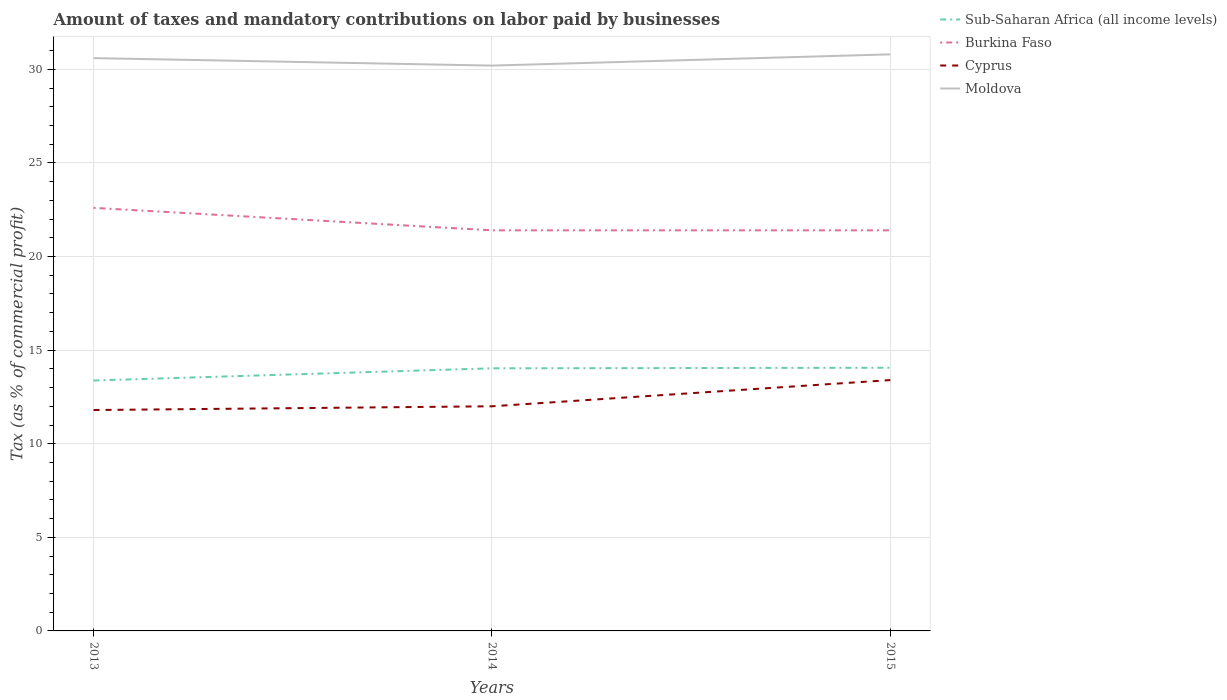How many different coloured lines are there?
Your answer should be compact. 4. Across all years, what is the maximum percentage of taxes paid by businesses in Sub-Saharan Africa (all income levels)?
Provide a short and direct response. 13.38. What is the total percentage of taxes paid by businesses in Sub-Saharan Africa (all income levels) in the graph?
Offer a very short reply. -0.68. What is the difference between the highest and the second highest percentage of taxes paid by businesses in Sub-Saharan Africa (all income levels)?
Provide a succinct answer. 0.68. Is the percentage of taxes paid by businesses in Sub-Saharan Africa (all income levels) strictly greater than the percentage of taxes paid by businesses in Burkina Faso over the years?
Ensure brevity in your answer.  Yes. What is the difference between two consecutive major ticks on the Y-axis?
Provide a succinct answer. 5. Does the graph contain any zero values?
Give a very brief answer. No. How many legend labels are there?
Provide a succinct answer. 4. How are the legend labels stacked?
Give a very brief answer. Vertical. What is the title of the graph?
Give a very brief answer. Amount of taxes and mandatory contributions on labor paid by businesses. Does "Ecuador" appear as one of the legend labels in the graph?
Make the answer very short. No. What is the label or title of the Y-axis?
Provide a succinct answer. Tax (as % of commercial profit). What is the Tax (as % of commercial profit) of Sub-Saharan Africa (all income levels) in 2013?
Offer a terse response. 13.38. What is the Tax (as % of commercial profit) of Burkina Faso in 2013?
Your answer should be compact. 22.6. What is the Tax (as % of commercial profit) of Moldova in 2013?
Your answer should be very brief. 30.6. What is the Tax (as % of commercial profit) in Sub-Saharan Africa (all income levels) in 2014?
Provide a succinct answer. 14.03. What is the Tax (as % of commercial profit) of Burkina Faso in 2014?
Your answer should be compact. 21.4. What is the Tax (as % of commercial profit) in Cyprus in 2014?
Keep it short and to the point. 12. What is the Tax (as % of commercial profit) of Moldova in 2014?
Offer a terse response. 30.2. What is the Tax (as % of commercial profit) of Sub-Saharan Africa (all income levels) in 2015?
Offer a very short reply. 14.06. What is the Tax (as % of commercial profit) in Burkina Faso in 2015?
Offer a very short reply. 21.4. What is the Tax (as % of commercial profit) of Moldova in 2015?
Provide a succinct answer. 30.8. Across all years, what is the maximum Tax (as % of commercial profit) of Sub-Saharan Africa (all income levels)?
Provide a short and direct response. 14.06. Across all years, what is the maximum Tax (as % of commercial profit) of Burkina Faso?
Your answer should be very brief. 22.6. Across all years, what is the maximum Tax (as % of commercial profit) in Moldova?
Keep it short and to the point. 30.8. Across all years, what is the minimum Tax (as % of commercial profit) in Sub-Saharan Africa (all income levels)?
Offer a very short reply. 13.38. Across all years, what is the minimum Tax (as % of commercial profit) in Burkina Faso?
Offer a very short reply. 21.4. Across all years, what is the minimum Tax (as % of commercial profit) in Cyprus?
Keep it short and to the point. 11.8. Across all years, what is the minimum Tax (as % of commercial profit) of Moldova?
Your answer should be compact. 30.2. What is the total Tax (as % of commercial profit) in Sub-Saharan Africa (all income levels) in the graph?
Your answer should be very brief. 41.46. What is the total Tax (as % of commercial profit) of Burkina Faso in the graph?
Offer a terse response. 65.4. What is the total Tax (as % of commercial profit) of Cyprus in the graph?
Provide a succinct answer. 37.2. What is the total Tax (as % of commercial profit) of Moldova in the graph?
Offer a very short reply. 91.6. What is the difference between the Tax (as % of commercial profit) in Sub-Saharan Africa (all income levels) in 2013 and that in 2014?
Your answer should be very brief. -0.65. What is the difference between the Tax (as % of commercial profit) in Cyprus in 2013 and that in 2014?
Give a very brief answer. -0.2. What is the difference between the Tax (as % of commercial profit) in Sub-Saharan Africa (all income levels) in 2013 and that in 2015?
Provide a succinct answer. -0.68. What is the difference between the Tax (as % of commercial profit) of Moldova in 2013 and that in 2015?
Keep it short and to the point. -0.2. What is the difference between the Tax (as % of commercial profit) in Sub-Saharan Africa (all income levels) in 2014 and that in 2015?
Offer a very short reply. -0.03. What is the difference between the Tax (as % of commercial profit) of Cyprus in 2014 and that in 2015?
Your response must be concise. -1.4. What is the difference between the Tax (as % of commercial profit) in Moldova in 2014 and that in 2015?
Make the answer very short. -0.6. What is the difference between the Tax (as % of commercial profit) of Sub-Saharan Africa (all income levels) in 2013 and the Tax (as % of commercial profit) of Burkina Faso in 2014?
Offer a very short reply. -8.02. What is the difference between the Tax (as % of commercial profit) in Sub-Saharan Africa (all income levels) in 2013 and the Tax (as % of commercial profit) in Cyprus in 2014?
Your answer should be compact. 1.38. What is the difference between the Tax (as % of commercial profit) of Sub-Saharan Africa (all income levels) in 2013 and the Tax (as % of commercial profit) of Moldova in 2014?
Make the answer very short. -16.82. What is the difference between the Tax (as % of commercial profit) in Burkina Faso in 2013 and the Tax (as % of commercial profit) in Moldova in 2014?
Provide a succinct answer. -7.6. What is the difference between the Tax (as % of commercial profit) in Cyprus in 2013 and the Tax (as % of commercial profit) in Moldova in 2014?
Give a very brief answer. -18.4. What is the difference between the Tax (as % of commercial profit) of Sub-Saharan Africa (all income levels) in 2013 and the Tax (as % of commercial profit) of Burkina Faso in 2015?
Ensure brevity in your answer.  -8.02. What is the difference between the Tax (as % of commercial profit) in Sub-Saharan Africa (all income levels) in 2013 and the Tax (as % of commercial profit) in Cyprus in 2015?
Provide a succinct answer. -0.02. What is the difference between the Tax (as % of commercial profit) of Sub-Saharan Africa (all income levels) in 2013 and the Tax (as % of commercial profit) of Moldova in 2015?
Offer a terse response. -17.42. What is the difference between the Tax (as % of commercial profit) of Cyprus in 2013 and the Tax (as % of commercial profit) of Moldova in 2015?
Provide a succinct answer. -19. What is the difference between the Tax (as % of commercial profit) of Sub-Saharan Africa (all income levels) in 2014 and the Tax (as % of commercial profit) of Burkina Faso in 2015?
Your answer should be compact. -7.37. What is the difference between the Tax (as % of commercial profit) in Sub-Saharan Africa (all income levels) in 2014 and the Tax (as % of commercial profit) in Cyprus in 2015?
Keep it short and to the point. 0.63. What is the difference between the Tax (as % of commercial profit) in Sub-Saharan Africa (all income levels) in 2014 and the Tax (as % of commercial profit) in Moldova in 2015?
Make the answer very short. -16.77. What is the difference between the Tax (as % of commercial profit) of Cyprus in 2014 and the Tax (as % of commercial profit) of Moldova in 2015?
Make the answer very short. -18.8. What is the average Tax (as % of commercial profit) in Sub-Saharan Africa (all income levels) per year?
Make the answer very short. 13.82. What is the average Tax (as % of commercial profit) of Burkina Faso per year?
Offer a terse response. 21.8. What is the average Tax (as % of commercial profit) in Cyprus per year?
Offer a terse response. 12.4. What is the average Tax (as % of commercial profit) in Moldova per year?
Keep it short and to the point. 30.53. In the year 2013, what is the difference between the Tax (as % of commercial profit) of Sub-Saharan Africa (all income levels) and Tax (as % of commercial profit) of Burkina Faso?
Provide a short and direct response. -9.22. In the year 2013, what is the difference between the Tax (as % of commercial profit) in Sub-Saharan Africa (all income levels) and Tax (as % of commercial profit) in Cyprus?
Offer a terse response. 1.58. In the year 2013, what is the difference between the Tax (as % of commercial profit) of Sub-Saharan Africa (all income levels) and Tax (as % of commercial profit) of Moldova?
Provide a succinct answer. -17.22. In the year 2013, what is the difference between the Tax (as % of commercial profit) of Cyprus and Tax (as % of commercial profit) of Moldova?
Your response must be concise. -18.8. In the year 2014, what is the difference between the Tax (as % of commercial profit) in Sub-Saharan Africa (all income levels) and Tax (as % of commercial profit) in Burkina Faso?
Your answer should be compact. -7.37. In the year 2014, what is the difference between the Tax (as % of commercial profit) of Sub-Saharan Africa (all income levels) and Tax (as % of commercial profit) of Cyprus?
Make the answer very short. 2.03. In the year 2014, what is the difference between the Tax (as % of commercial profit) of Sub-Saharan Africa (all income levels) and Tax (as % of commercial profit) of Moldova?
Provide a short and direct response. -16.17. In the year 2014, what is the difference between the Tax (as % of commercial profit) in Burkina Faso and Tax (as % of commercial profit) in Cyprus?
Keep it short and to the point. 9.4. In the year 2014, what is the difference between the Tax (as % of commercial profit) in Burkina Faso and Tax (as % of commercial profit) in Moldova?
Your answer should be compact. -8.8. In the year 2014, what is the difference between the Tax (as % of commercial profit) of Cyprus and Tax (as % of commercial profit) of Moldova?
Provide a succinct answer. -18.2. In the year 2015, what is the difference between the Tax (as % of commercial profit) in Sub-Saharan Africa (all income levels) and Tax (as % of commercial profit) in Burkina Faso?
Offer a very short reply. -7.34. In the year 2015, what is the difference between the Tax (as % of commercial profit) of Sub-Saharan Africa (all income levels) and Tax (as % of commercial profit) of Cyprus?
Your response must be concise. 0.66. In the year 2015, what is the difference between the Tax (as % of commercial profit) in Sub-Saharan Africa (all income levels) and Tax (as % of commercial profit) in Moldova?
Ensure brevity in your answer.  -16.74. In the year 2015, what is the difference between the Tax (as % of commercial profit) of Burkina Faso and Tax (as % of commercial profit) of Cyprus?
Provide a succinct answer. 8. In the year 2015, what is the difference between the Tax (as % of commercial profit) of Cyprus and Tax (as % of commercial profit) of Moldova?
Your answer should be very brief. -17.4. What is the ratio of the Tax (as % of commercial profit) of Sub-Saharan Africa (all income levels) in 2013 to that in 2014?
Ensure brevity in your answer.  0.95. What is the ratio of the Tax (as % of commercial profit) in Burkina Faso in 2013 to that in 2014?
Offer a terse response. 1.06. What is the ratio of the Tax (as % of commercial profit) in Cyprus in 2013 to that in 2014?
Give a very brief answer. 0.98. What is the ratio of the Tax (as % of commercial profit) in Moldova in 2013 to that in 2014?
Offer a very short reply. 1.01. What is the ratio of the Tax (as % of commercial profit) of Sub-Saharan Africa (all income levels) in 2013 to that in 2015?
Provide a succinct answer. 0.95. What is the ratio of the Tax (as % of commercial profit) in Burkina Faso in 2013 to that in 2015?
Your response must be concise. 1.06. What is the ratio of the Tax (as % of commercial profit) in Cyprus in 2013 to that in 2015?
Provide a succinct answer. 0.88. What is the ratio of the Tax (as % of commercial profit) of Cyprus in 2014 to that in 2015?
Your answer should be compact. 0.9. What is the ratio of the Tax (as % of commercial profit) in Moldova in 2014 to that in 2015?
Offer a terse response. 0.98. What is the difference between the highest and the second highest Tax (as % of commercial profit) in Sub-Saharan Africa (all income levels)?
Give a very brief answer. 0.03. What is the difference between the highest and the second highest Tax (as % of commercial profit) of Burkina Faso?
Offer a terse response. 1.2. What is the difference between the highest and the second highest Tax (as % of commercial profit) in Cyprus?
Give a very brief answer. 1.4. What is the difference between the highest and the second highest Tax (as % of commercial profit) of Moldova?
Give a very brief answer. 0.2. What is the difference between the highest and the lowest Tax (as % of commercial profit) of Sub-Saharan Africa (all income levels)?
Ensure brevity in your answer.  0.68. What is the difference between the highest and the lowest Tax (as % of commercial profit) in Cyprus?
Offer a terse response. 1.6. What is the difference between the highest and the lowest Tax (as % of commercial profit) of Moldova?
Offer a very short reply. 0.6. 